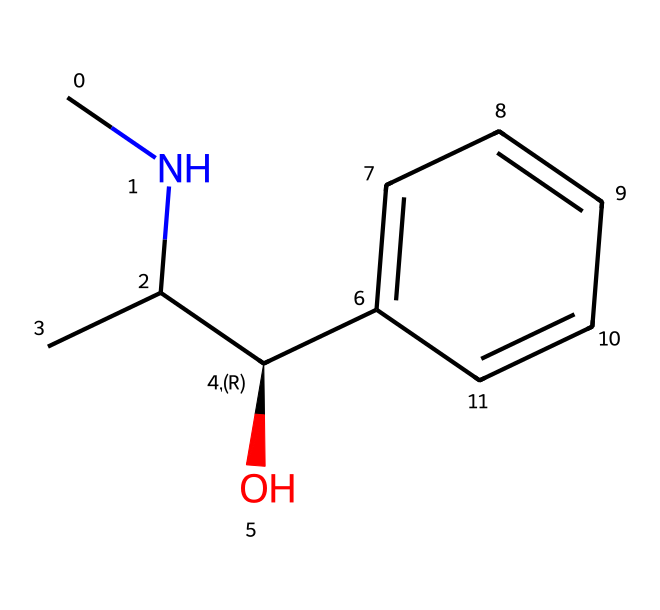What is the name of this chemical? The chemical structure represented by the SMILES notation indicates it is ephedrine, which is a well-known alkaloid.
Answer: ephedrine How many carbon atoms are in the structure? By inspecting the SMILES, we can count each carbon atom represented. The structure contains 10 carbon atoms.
Answer: 10 How many nitrogen atoms are present in this chemical? From the SMILES, we can see there is one nitrogen atom, indicated by the letter "N" in the structure.
Answer: 1 What is the primary functional group in ephedrine? The structure exhibits a hydroxyl group (-OH), which is characteristic of ephedrine, influencing its solubility and reactivity.
Answer: hydroxyl Is this compound considered a stimulant? Ephedrine is classified as a stimulant due to its ability to increase heart rate and promote alertness, commonly used in military rations.
Answer: yes What type of molecule is ephedrine classified as? As ephedrine contains a nitrogen atom within its structure and is derived from plant sources, it is classified as an alkaloid, which is distinct for its nitrogen content.
Answer: alkaloid How does the stereochemistry affect ephedrine's activity? The stereocenter in ephedrine's structure contributes to its specific biological activity and receptor interactions, which is crucial for its stimulant effects.
Answer: critical 